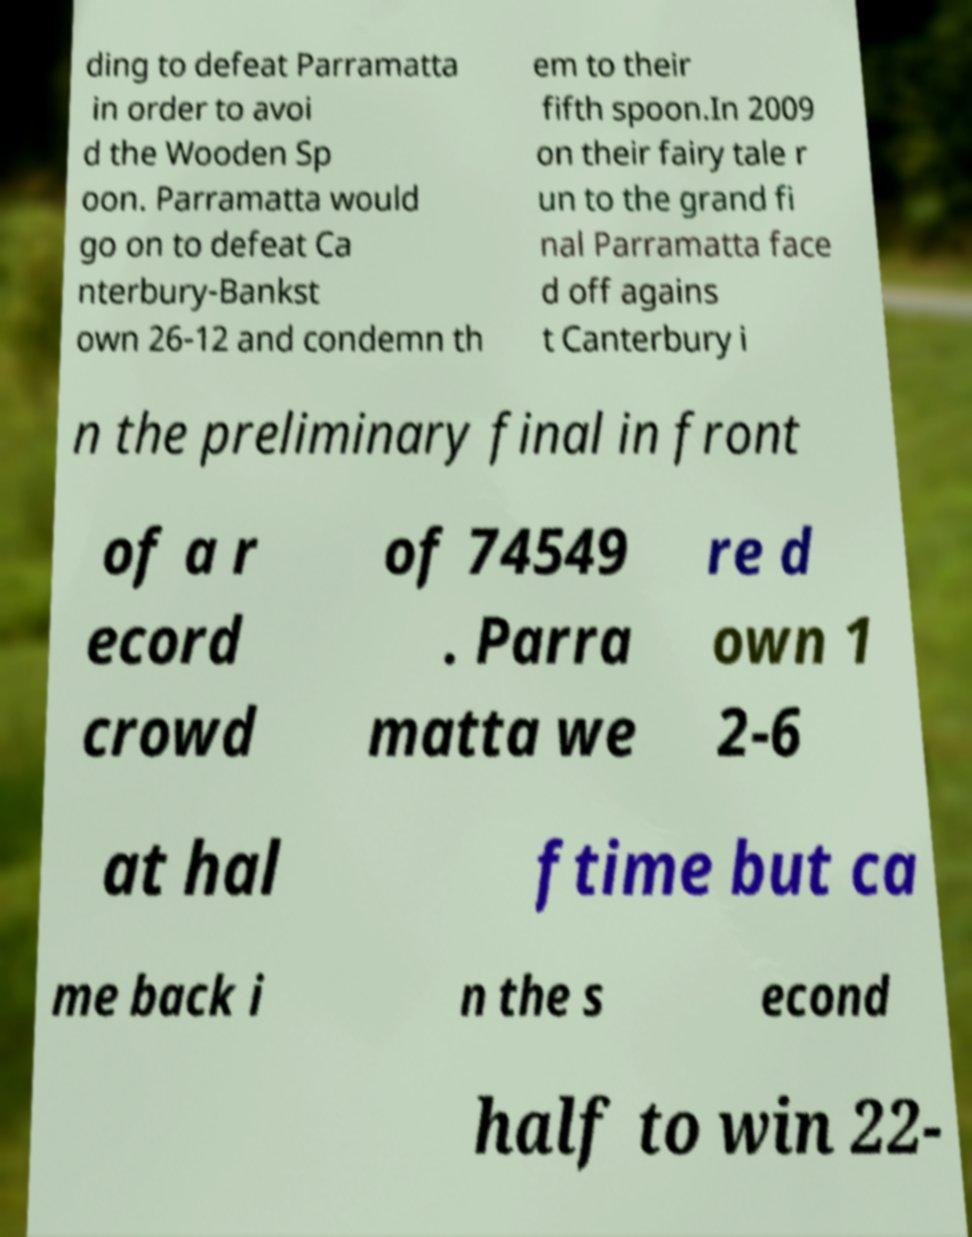I need the written content from this picture converted into text. Can you do that? ding to defeat Parramatta in order to avoi d the Wooden Sp oon. Parramatta would go on to defeat Ca nterbury-Bankst own 26-12 and condemn th em to their fifth spoon.In 2009 on their fairy tale r un to the grand fi nal Parramatta face d off agains t Canterbury i n the preliminary final in front of a r ecord crowd of 74549 . Parra matta we re d own 1 2-6 at hal ftime but ca me back i n the s econd half to win 22- 